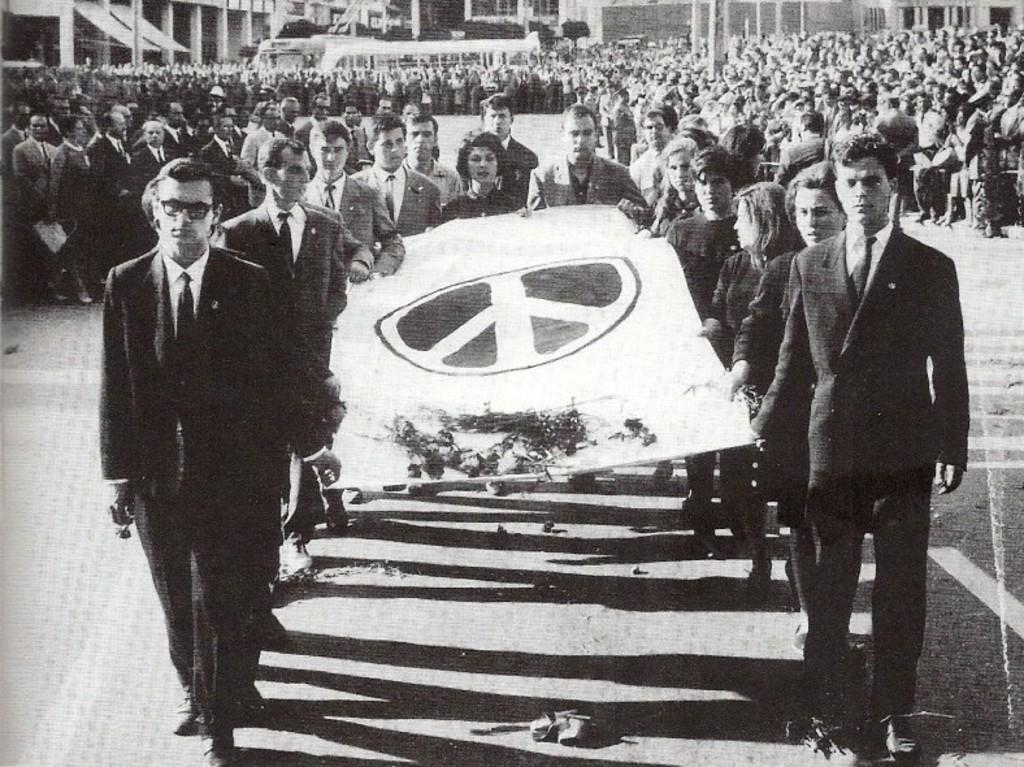What is the color scheme of the image? The image is black and white. What can be seen in the image? There are people in the image. What are some people doing in the image? Some people are holding a banner. What is visible in the background of the image? There are buildings in the background of the image. What is at the bottom of the image? There is a road at the bottom of the image. What type of celery is being used as a prop in the image? There is no celery present in the image. What time of day is depicted in the image? The image does not provide any information about the time of day. 